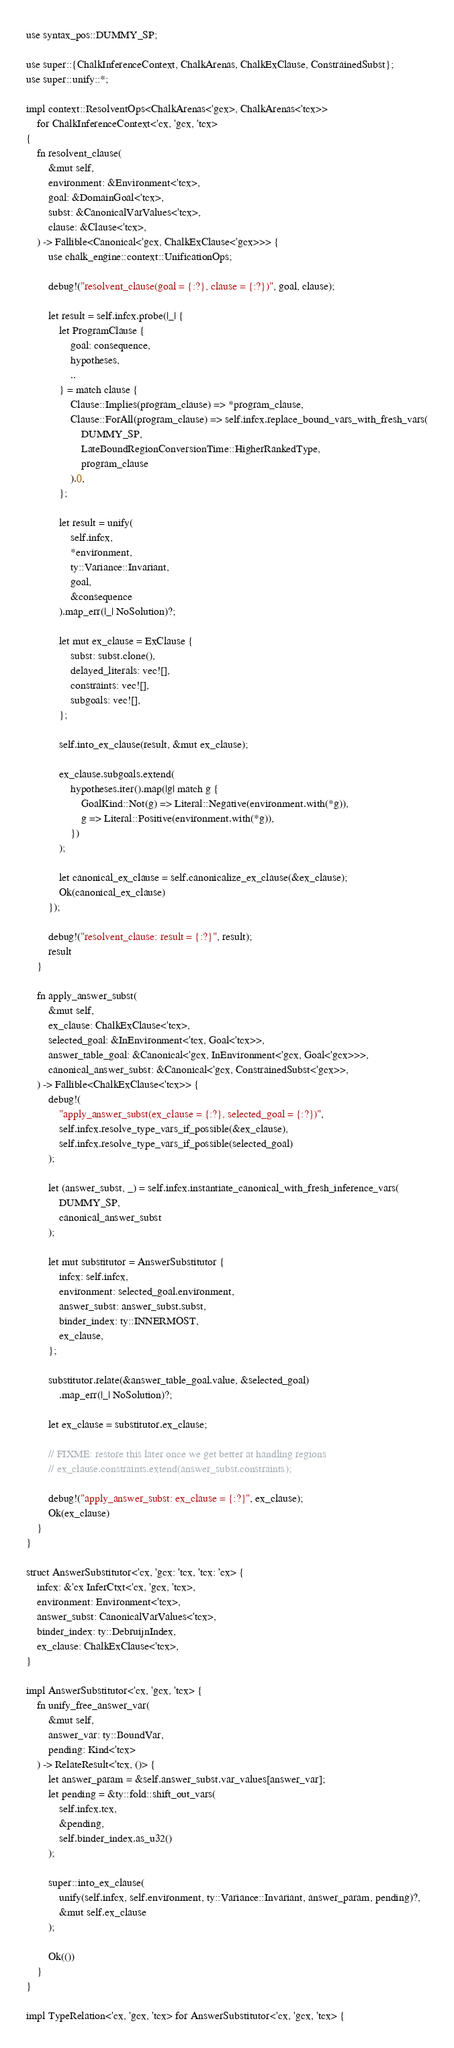Convert code to text. <code><loc_0><loc_0><loc_500><loc_500><_Rust_>use syntax_pos::DUMMY_SP;

use super::{ChalkInferenceContext, ChalkArenas, ChalkExClause, ConstrainedSubst};
use super::unify::*;

impl context::ResolventOps<ChalkArenas<'gcx>, ChalkArenas<'tcx>>
    for ChalkInferenceContext<'cx, 'gcx, 'tcx>
{
    fn resolvent_clause(
        &mut self,
        environment: &Environment<'tcx>,
        goal: &DomainGoal<'tcx>,
        subst: &CanonicalVarValues<'tcx>,
        clause: &Clause<'tcx>,
    ) -> Fallible<Canonical<'gcx, ChalkExClause<'gcx>>> {
        use chalk_engine::context::UnificationOps;

        debug!("resolvent_clause(goal = {:?}, clause = {:?})", goal, clause);

        let result = self.infcx.probe(|_| {
            let ProgramClause {
                goal: consequence,
                hypotheses,
                ..
            } = match clause {
                Clause::Implies(program_clause) => *program_clause,
                Clause::ForAll(program_clause) => self.infcx.replace_bound_vars_with_fresh_vars(
                    DUMMY_SP,
                    LateBoundRegionConversionTime::HigherRankedType,
                    program_clause
                ).0,
            };

            let result = unify(
                self.infcx,
                *environment,
                ty::Variance::Invariant,
                goal,
                &consequence
            ).map_err(|_| NoSolution)?;

            let mut ex_clause = ExClause {
                subst: subst.clone(),
                delayed_literals: vec![],
                constraints: vec![],
                subgoals: vec![],
            };

            self.into_ex_clause(result, &mut ex_clause);

            ex_clause.subgoals.extend(
                hypotheses.iter().map(|g| match g {
                    GoalKind::Not(g) => Literal::Negative(environment.with(*g)),
                    g => Literal::Positive(environment.with(*g)),
                })
            );

            let canonical_ex_clause = self.canonicalize_ex_clause(&ex_clause);
            Ok(canonical_ex_clause)
        });

        debug!("resolvent_clause: result = {:?}", result);
        result
    }

    fn apply_answer_subst(
        &mut self,
        ex_clause: ChalkExClause<'tcx>,
        selected_goal: &InEnvironment<'tcx, Goal<'tcx>>,
        answer_table_goal: &Canonical<'gcx, InEnvironment<'gcx, Goal<'gcx>>>,
        canonical_answer_subst: &Canonical<'gcx, ConstrainedSubst<'gcx>>,
    ) -> Fallible<ChalkExClause<'tcx>> {
        debug!(
            "apply_answer_subst(ex_clause = {:?}, selected_goal = {:?})",
            self.infcx.resolve_type_vars_if_possible(&ex_clause),
            self.infcx.resolve_type_vars_if_possible(selected_goal)
        );

        let (answer_subst, _) = self.infcx.instantiate_canonical_with_fresh_inference_vars(
            DUMMY_SP,
            canonical_answer_subst
        );

        let mut substitutor = AnswerSubstitutor {
            infcx: self.infcx,
            environment: selected_goal.environment,
            answer_subst: answer_subst.subst,
            binder_index: ty::INNERMOST,
            ex_clause,
        };

        substitutor.relate(&answer_table_goal.value, &selected_goal)
            .map_err(|_| NoSolution)?;

        let ex_clause = substitutor.ex_clause;

        // FIXME: restore this later once we get better at handling regions
        // ex_clause.constraints.extend(answer_subst.constraints);

        debug!("apply_answer_subst: ex_clause = {:?}", ex_clause);
        Ok(ex_clause)
    }
}

struct AnswerSubstitutor<'cx, 'gcx: 'tcx, 'tcx: 'cx> {
    infcx: &'cx InferCtxt<'cx, 'gcx, 'tcx>,
    environment: Environment<'tcx>,
    answer_subst: CanonicalVarValues<'tcx>,
    binder_index: ty::DebruijnIndex,
    ex_clause: ChalkExClause<'tcx>,
}

impl AnswerSubstitutor<'cx, 'gcx, 'tcx> {
    fn unify_free_answer_var(
        &mut self,
        answer_var: ty::BoundVar,
        pending: Kind<'tcx>
    ) -> RelateResult<'tcx, ()> {
        let answer_param = &self.answer_subst.var_values[answer_var];
        let pending = &ty::fold::shift_out_vars(
            self.infcx.tcx,
            &pending,
            self.binder_index.as_u32()
        );

        super::into_ex_clause(
            unify(self.infcx, self.environment, ty::Variance::Invariant, answer_param, pending)?,
            &mut self.ex_clause
        );

        Ok(())
    }
}

impl TypeRelation<'cx, 'gcx, 'tcx> for AnswerSubstitutor<'cx, 'gcx, 'tcx> {</code> 